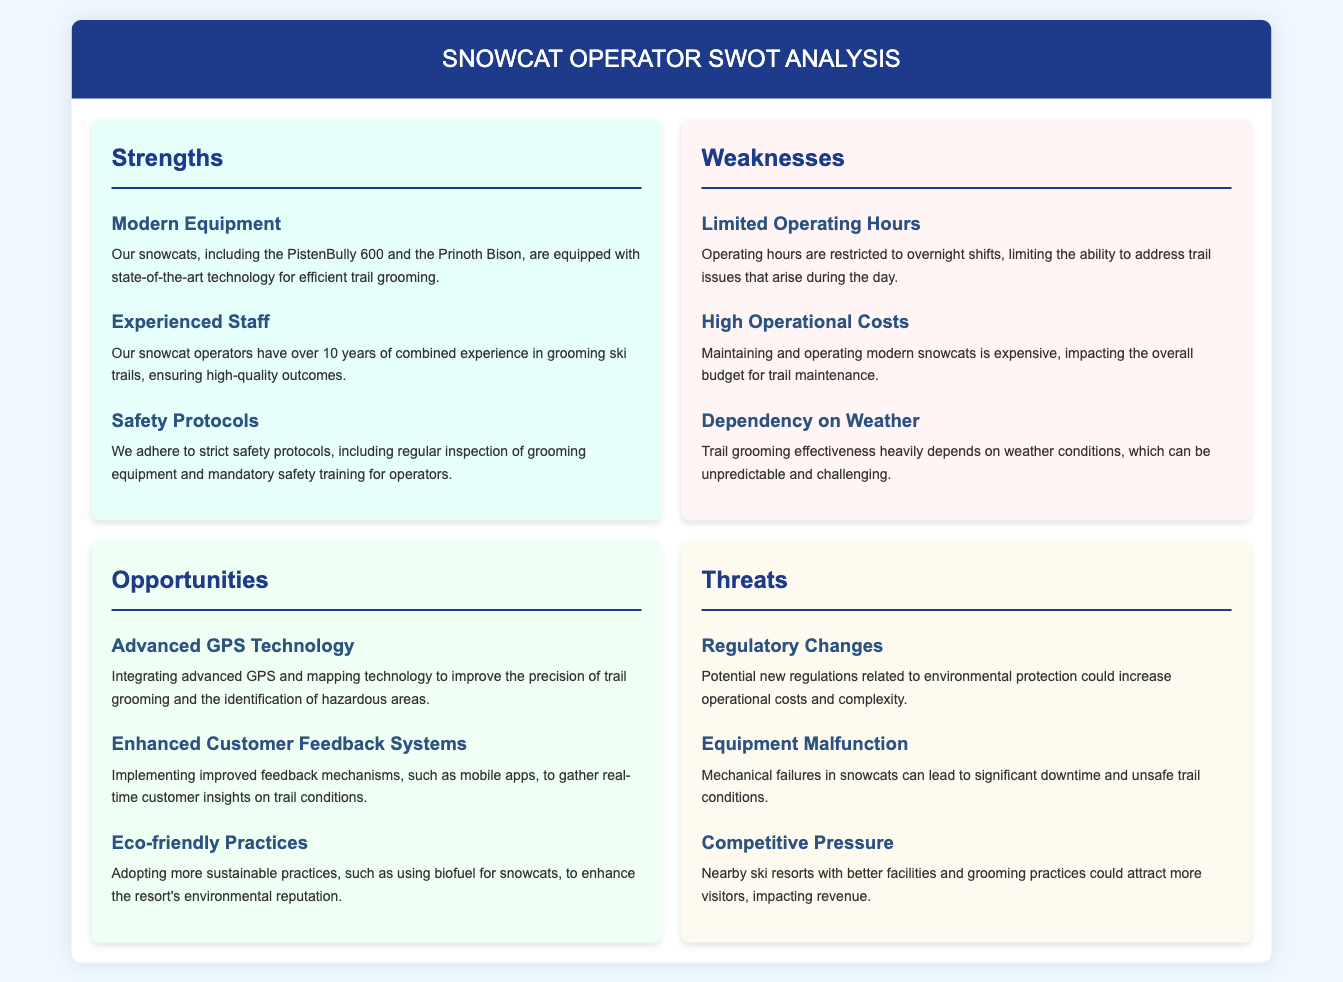What is one of the strengths in the SWOT analysis? One of the strengths listed is "Modern Equipment" which refers to the state-of-the-art technology used for trail grooming.
Answer: Modern Equipment What challenges are mentioned under weaknesses? The weaknesses section highlights challenges like "Limited Operating Hours," which affects the response to trail issues.
Answer: Limited Operating Hours What opportunity involves technology enhancement? The opportunity to integrate "Advanced GPS Technology" for better trail grooming precision is mentioned.
Answer: Advanced GPS Technology How many years of experience do the snowcat operators have collectively? The document states that the operators have "over 10 years of combined experience" in grooming trails.
Answer: 10 years Which threat relates to environmental regulations? The document mentions "Regulatory Changes" as a potential threat impacting operational costs and complexity.
Answer: Regulatory Changes What is a key aspect of the safety mentioned in strengths? The strengths section emphasizes "Safety Protocols" that include regular inspections and training.
Answer: Safety Protocols How does customer feedback play a role in the opportunities? The analysis discusses "Enhanced Customer Feedback Systems" as a way to gather insights on trail conditions.
Answer: Enhanced Customer Feedback Systems What is the impact of weather mentioned in weaknesses? The document notes that "Dependency on Weather" affects the effectiveness of trail grooming due to unpredictable conditions.
Answer: Dependency on Weather What type of snowcat is mentioned in the strengths? The strengths section specifically mentions "PistenBully 600" as part of the modern equipment used.
Answer: PistenBully 600 